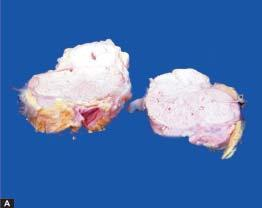what is surrounded by increased fat?
Answer the question using a single word or phrase. Matted mass of lymph nodes 